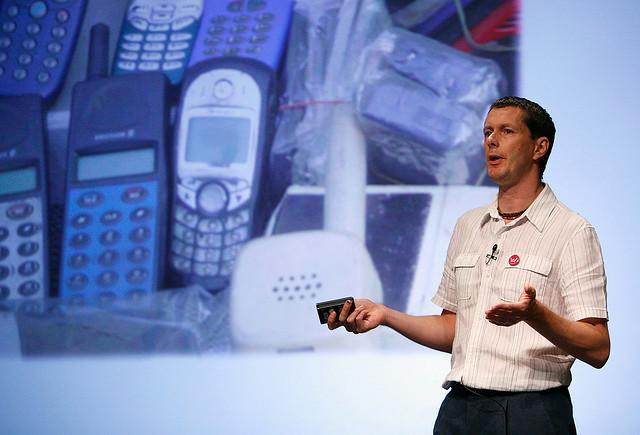What is the subject of the speech being given? Please explain your reasoning. cell phones. The subject is cell phones. 